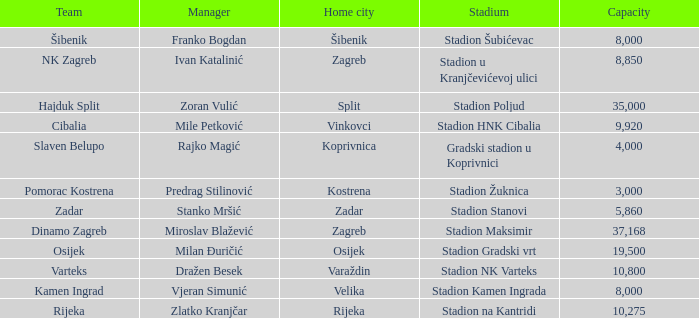What team that has a Home city of Zadar? Zadar. 